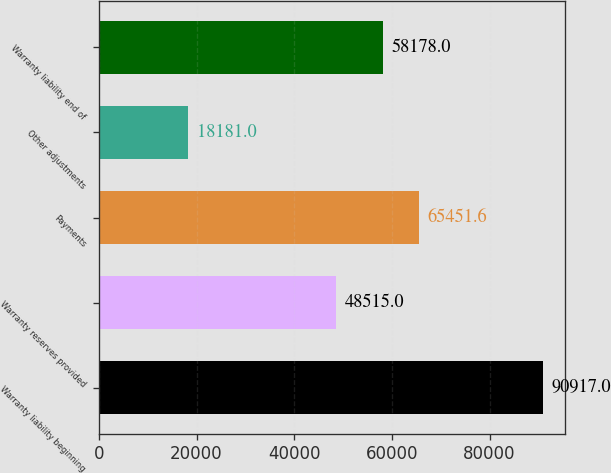<chart> <loc_0><loc_0><loc_500><loc_500><bar_chart><fcel>Warranty liability beginning<fcel>Warranty reserves provided<fcel>Payments<fcel>Other adjustments<fcel>Warranty liability end of<nl><fcel>90917<fcel>48515<fcel>65451.6<fcel>18181<fcel>58178<nl></chart> 